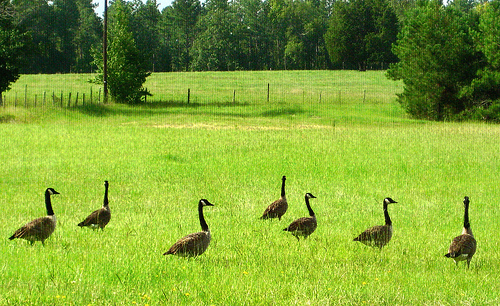<image>
Can you confirm if the bird is on the grass? Yes. Looking at the image, I can see the bird is positioned on top of the grass, with the grass providing support. 